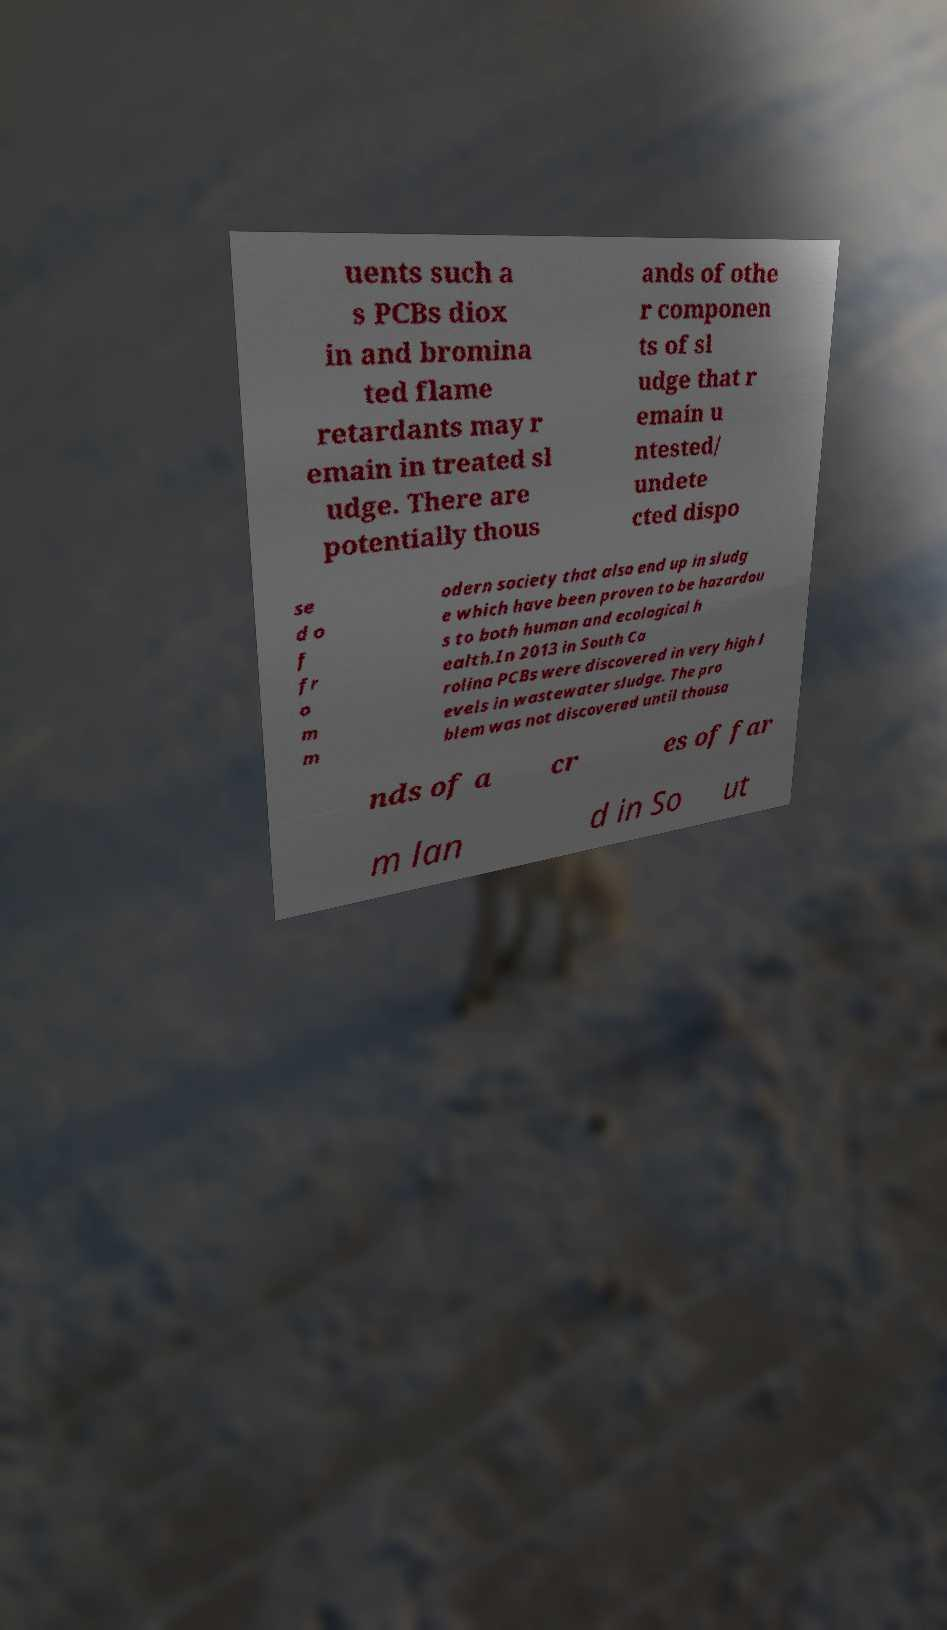Please read and relay the text visible in this image. What does it say? uents such a s PCBs diox in and bromina ted flame retardants may r emain in treated sl udge. There are potentially thous ands of othe r componen ts of sl udge that r emain u ntested/ undete cted dispo se d o f fr o m m odern society that also end up in sludg e which have been proven to be hazardou s to both human and ecological h ealth.In 2013 in South Ca rolina PCBs were discovered in very high l evels in wastewater sludge. The pro blem was not discovered until thousa nds of a cr es of far m lan d in So ut 